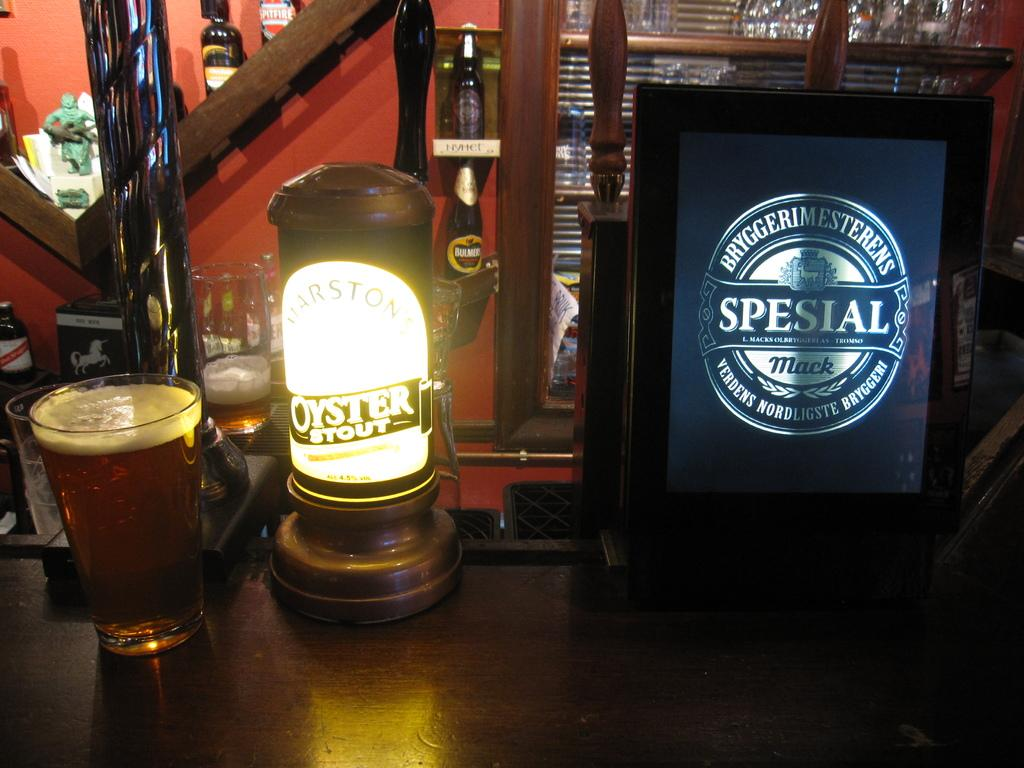<image>
Give a short and clear explanation of the subsequent image. a glass of beer next to a pump advertising Oyster stout 